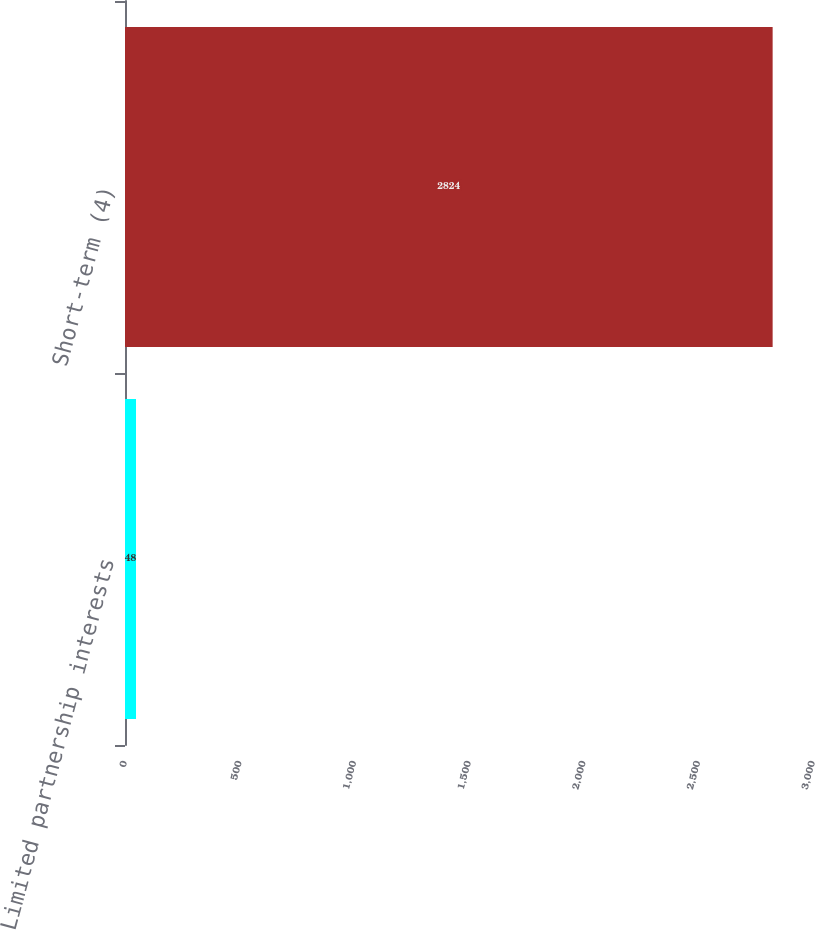<chart> <loc_0><loc_0><loc_500><loc_500><bar_chart><fcel>Limited partnership interests<fcel>Short-term (4)<nl><fcel>48<fcel>2824<nl></chart> 